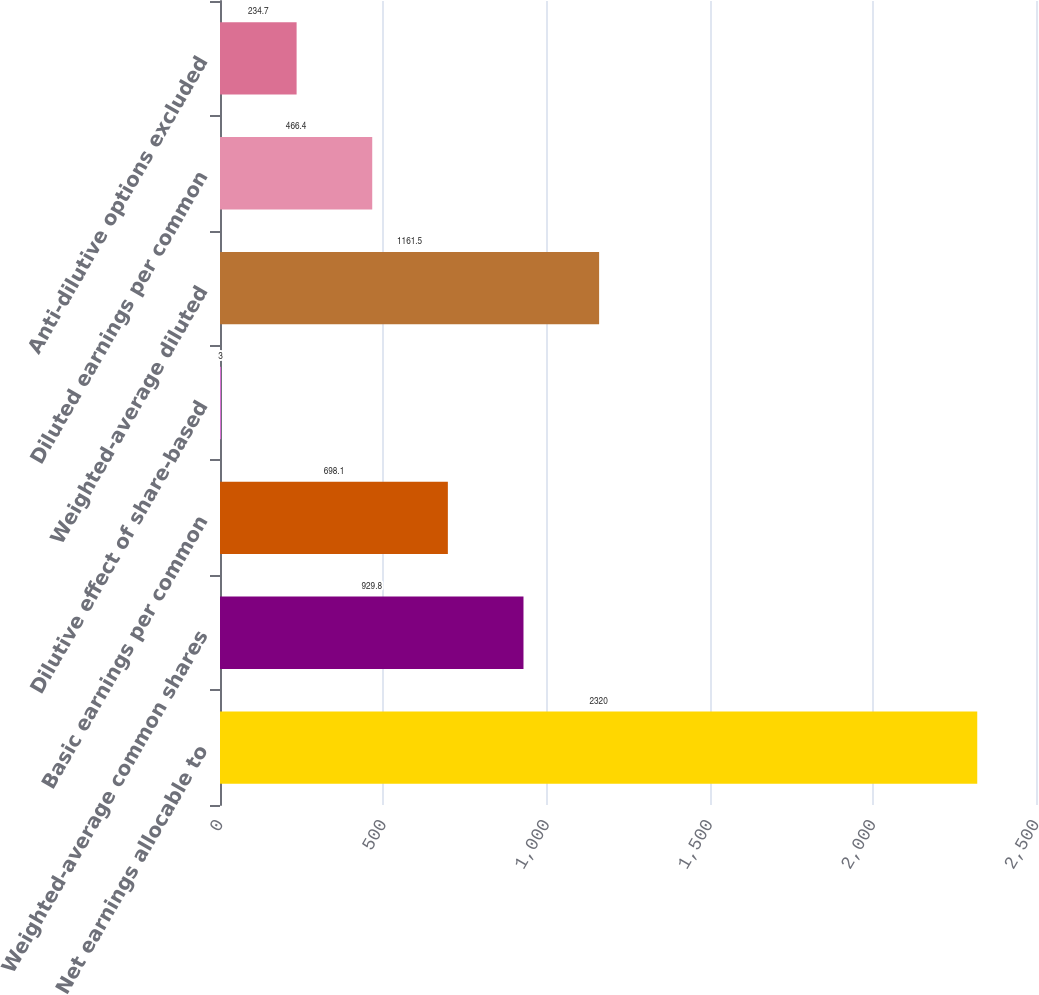<chart> <loc_0><loc_0><loc_500><loc_500><bar_chart><fcel>Net earnings allocable to<fcel>Weighted-average common shares<fcel>Basic earnings per common<fcel>Dilutive effect of share-based<fcel>Weighted-average diluted<fcel>Diluted earnings per common<fcel>Anti-dilutive options excluded<nl><fcel>2320<fcel>929.8<fcel>698.1<fcel>3<fcel>1161.5<fcel>466.4<fcel>234.7<nl></chart> 